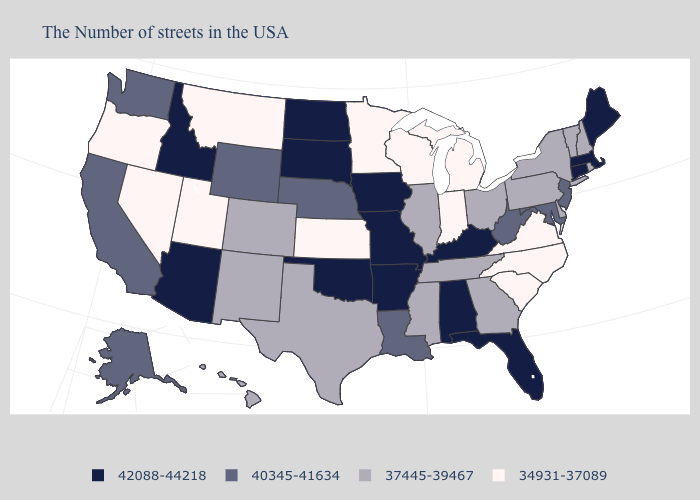Name the states that have a value in the range 42088-44218?
Concise answer only. Maine, Massachusetts, Connecticut, Florida, Kentucky, Alabama, Missouri, Arkansas, Iowa, Oklahoma, South Dakota, North Dakota, Arizona, Idaho. Name the states that have a value in the range 40345-41634?
Keep it brief. New Jersey, Maryland, West Virginia, Louisiana, Nebraska, Wyoming, California, Washington, Alaska. Among the states that border Louisiana , which have the lowest value?
Concise answer only. Mississippi, Texas. What is the value of Georgia?
Answer briefly. 37445-39467. How many symbols are there in the legend?
Answer briefly. 4. How many symbols are there in the legend?
Be succinct. 4. Name the states that have a value in the range 40345-41634?
Be succinct. New Jersey, Maryland, West Virginia, Louisiana, Nebraska, Wyoming, California, Washington, Alaska. What is the value of Iowa?
Write a very short answer. 42088-44218. Does the first symbol in the legend represent the smallest category?
Write a very short answer. No. Name the states that have a value in the range 34931-37089?
Keep it brief. Virginia, North Carolina, South Carolina, Michigan, Indiana, Wisconsin, Minnesota, Kansas, Utah, Montana, Nevada, Oregon. Name the states that have a value in the range 37445-39467?
Write a very short answer. Rhode Island, New Hampshire, Vermont, New York, Delaware, Pennsylvania, Ohio, Georgia, Tennessee, Illinois, Mississippi, Texas, Colorado, New Mexico, Hawaii. Name the states that have a value in the range 37445-39467?
Short answer required. Rhode Island, New Hampshire, Vermont, New York, Delaware, Pennsylvania, Ohio, Georgia, Tennessee, Illinois, Mississippi, Texas, Colorado, New Mexico, Hawaii. Among the states that border Nebraska , which have the highest value?
Short answer required. Missouri, Iowa, South Dakota. What is the lowest value in the Northeast?
Quick response, please. 37445-39467. Does Washington have a higher value than Arizona?
Give a very brief answer. No. 